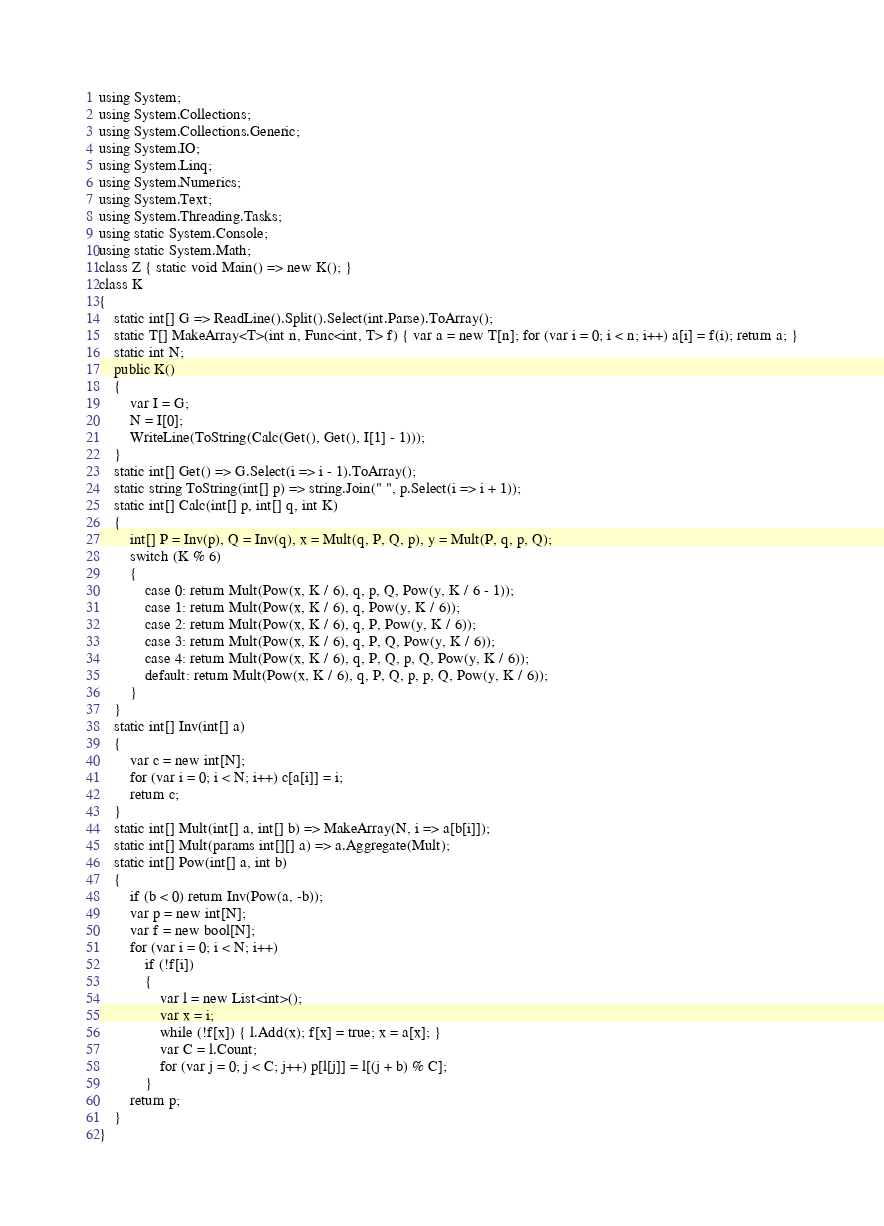<code> <loc_0><loc_0><loc_500><loc_500><_C#_>using System;
using System.Collections;
using System.Collections.Generic;
using System.IO;
using System.Linq;
using System.Numerics;
using System.Text;
using System.Threading.Tasks;
using static System.Console;
using static System.Math;
class Z { static void Main() => new K(); }
class K
{
	static int[] G => ReadLine().Split().Select(int.Parse).ToArray();
	static T[] MakeArray<T>(int n, Func<int, T> f) { var a = new T[n]; for (var i = 0; i < n; i++) a[i] = f(i); return a; }
	static int N;
	public K()
	{
		var I = G;
		N = I[0];
		WriteLine(ToString(Calc(Get(), Get(), I[1] - 1)));
	}
	static int[] Get() => G.Select(i => i - 1).ToArray();
	static string ToString(int[] p) => string.Join(" ", p.Select(i => i + 1));
	static int[] Calc(int[] p, int[] q, int K)
	{
		int[] P = Inv(p), Q = Inv(q), x = Mult(q, P, Q, p), y = Mult(P, q, p, Q);
		switch (K % 6)
		{
			case 0: return Mult(Pow(x, K / 6), q, p, Q, Pow(y, K / 6 - 1));
			case 1: return Mult(Pow(x, K / 6), q, Pow(y, K / 6));
			case 2: return Mult(Pow(x, K / 6), q, P, Pow(y, K / 6));
			case 3: return Mult(Pow(x, K / 6), q, P, Q, Pow(y, K / 6));
			case 4: return Mult(Pow(x, K / 6), q, P, Q, p, Q, Pow(y, K / 6));
			default: return Mult(Pow(x, K / 6), q, P, Q, p, p, Q, Pow(y, K / 6));
		}
	}
	static int[] Inv(int[] a)
	{
		var c = new int[N];
		for (var i = 0; i < N; i++) c[a[i]] = i;
		return c;
	}
	static int[] Mult(int[] a, int[] b) => MakeArray(N, i => a[b[i]]);
	static int[] Mult(params int[][] a) => a.Aggregate(Mult);
	static int[] Pow(int[] a, int b)
	{
		if (b < 0) return Inv(Pow(a, -b));
		var p = new int[N];
		var f = new bool[N];
		for (var i = 0; i < N; i++)
			if (!f[i])
			{
				var l = new List<int>();
				var x = i;
				while (!f[x]) { l.Add(x); f[x] = true; x = a[x]; }
				var C = l.Count;
				for (var j = 0; j < C; j++) p[l[j]] = l[(j + b) % C];
			}
		return p;
	}
}
</code> 